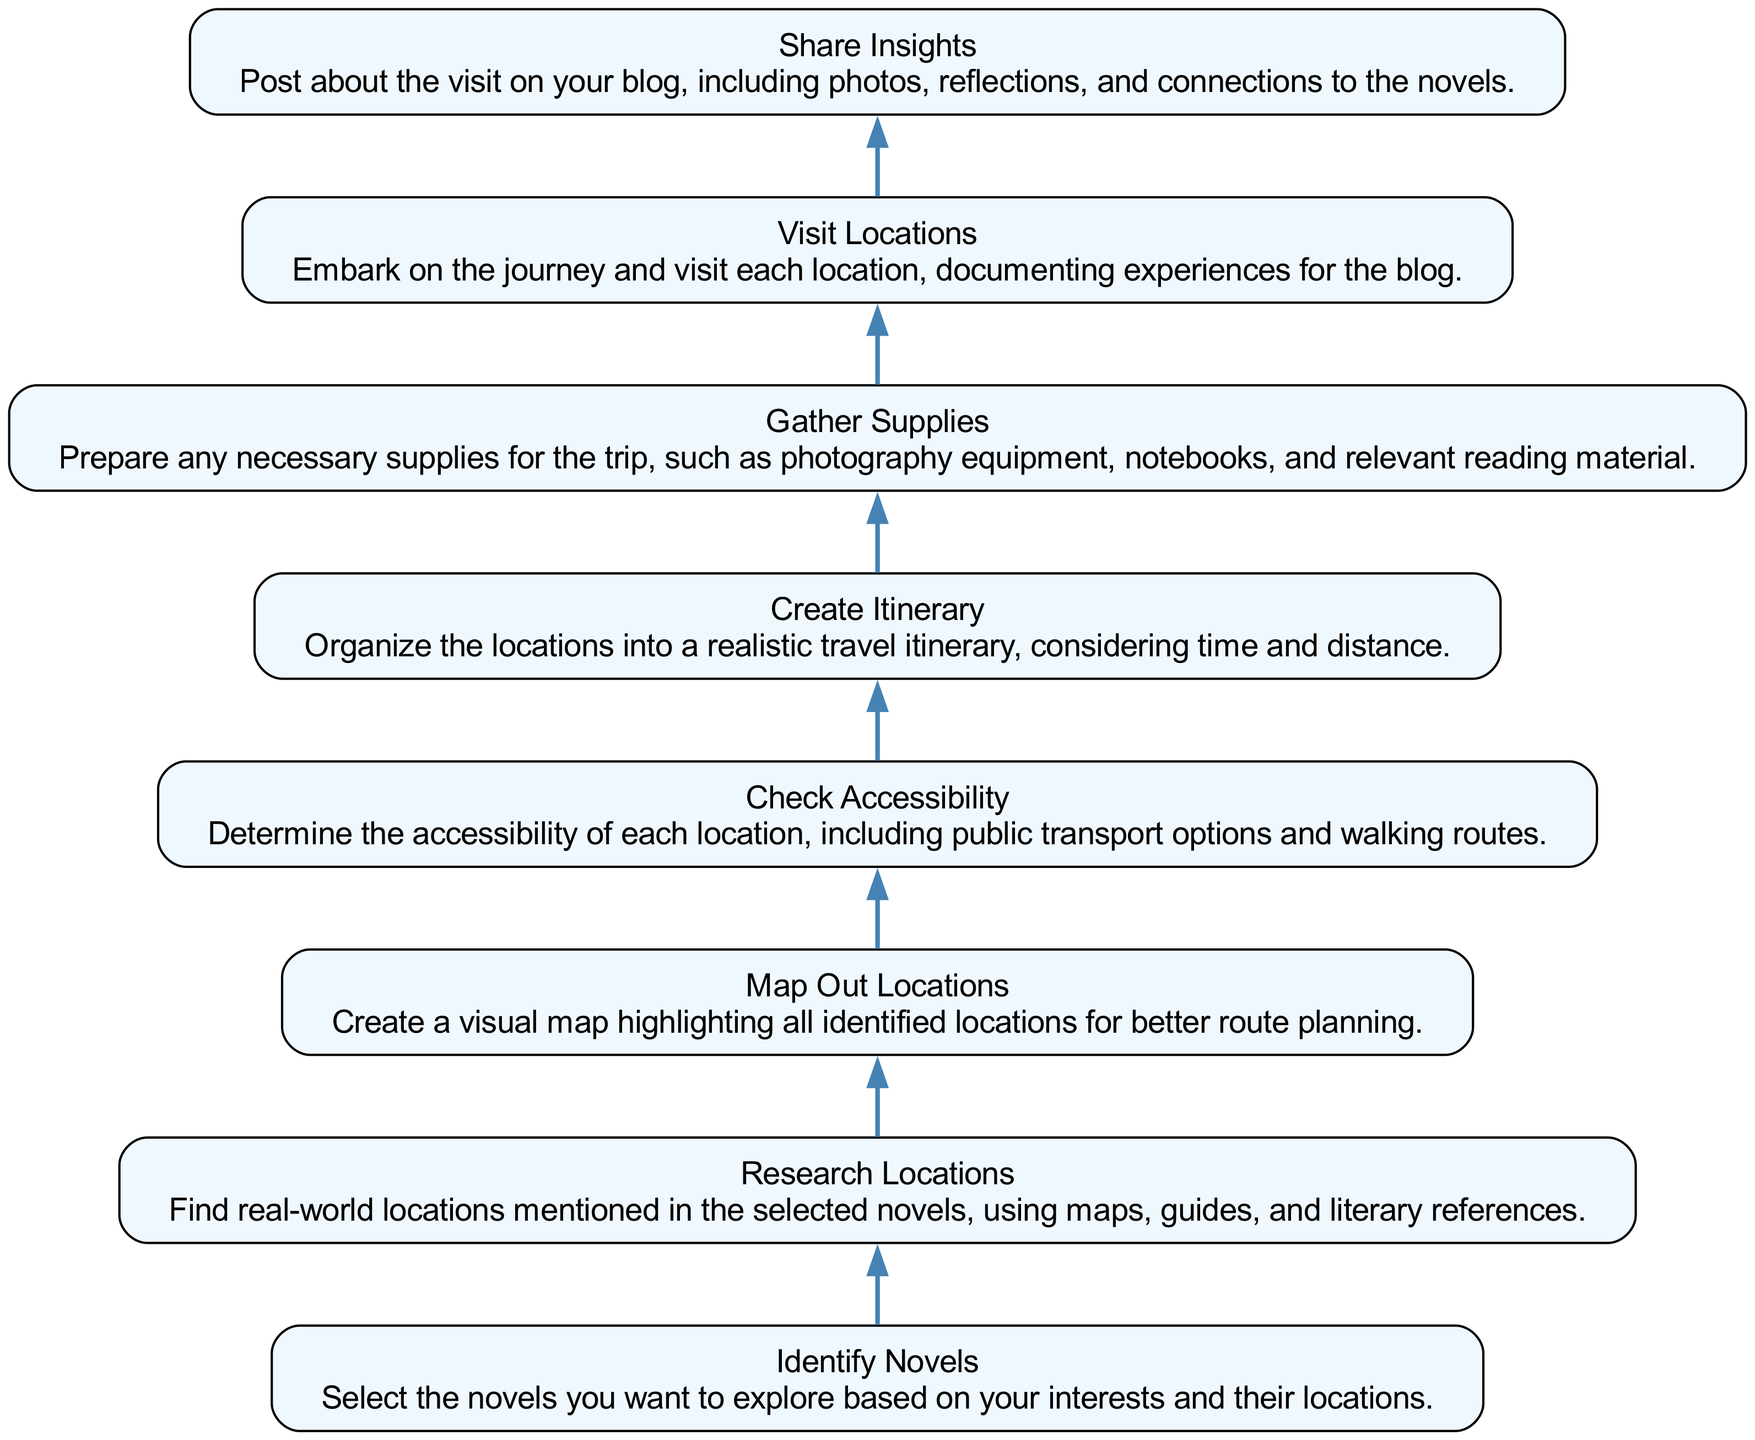What is the first step in the itinerary creation process? The first step in the flow chart is "Identify Novels," which involves selecting the novels based on personal interests and their locations.
Answer: Identify Novels How many total steps are present in the flow chart? There are eight steps listed in the diagram, ranging from identifying novels to sharing insights after visiting locations.
Answer: Eight What follows the "Map Out Locations" step? After "Map Out Locations," the next step is "Check Accessibility," which involves assessing the accessibility of each identified location.
Answer: Check Accessibility Which step involves documenting experiences? The step "Visit Locations" is where one embarks on the journey and documents experiences for the blog.
Answer: Visit Locations Which step requires preparation for the trip? The "Gather Supplies" step involves preparing all necessary supplies such as photography equipment and notebooks before the trip.
Answer: Gather Supplies What is the primary purpose of the "Share Insights" step? The "Share Insights" step serves the purpose of posting on your blog about the visit, including reflections, photos, and connections to the novels.
Answer: Share Insights How does the flow of the chart progress? The chart follows a bottom-up flow, with each step depending on the completion of the previous one, creating a logical sequence for route planning.
Answer: Bottom-up flow What is the relationship between "Research Locations" and "Map Out Locations"? "Research Locations" must be completed before moving on to "Map Out Locations," as the latter requires the identification of locations based on research.
Answer: Sequential relationship 